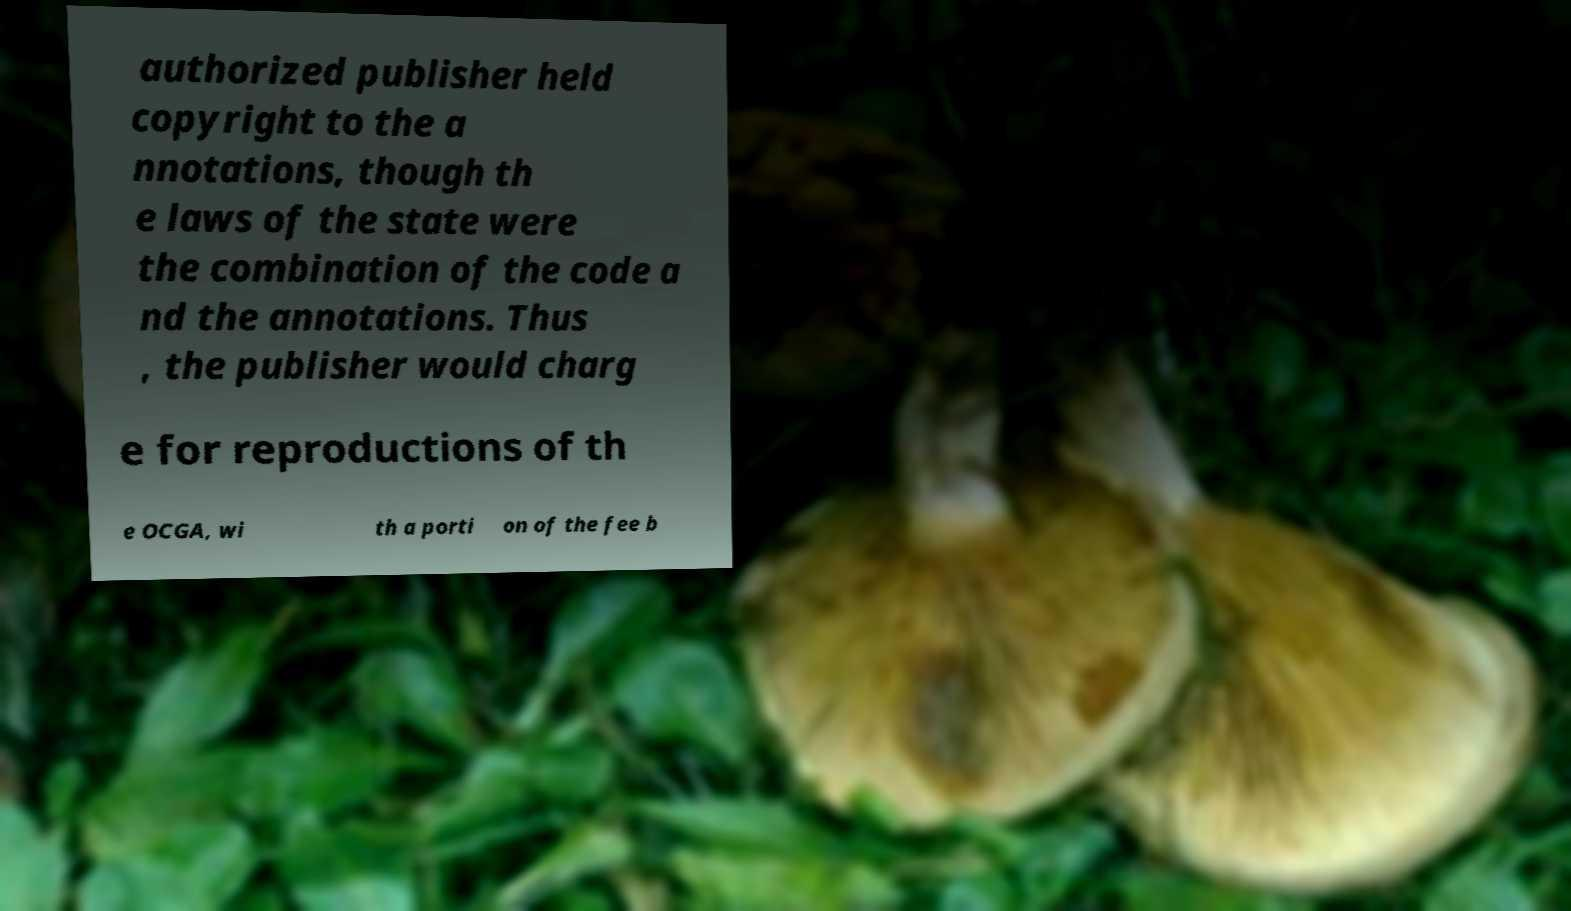Can you accurately transcribe the text from the provided image for me? authorized publisher held copyright to the a nnotations, though th e laws of the state were the combination of the code a nd the annotations. Thus , the publisher would charg e for reproductions of th e OCGA, wi th a porti on of the fee b 